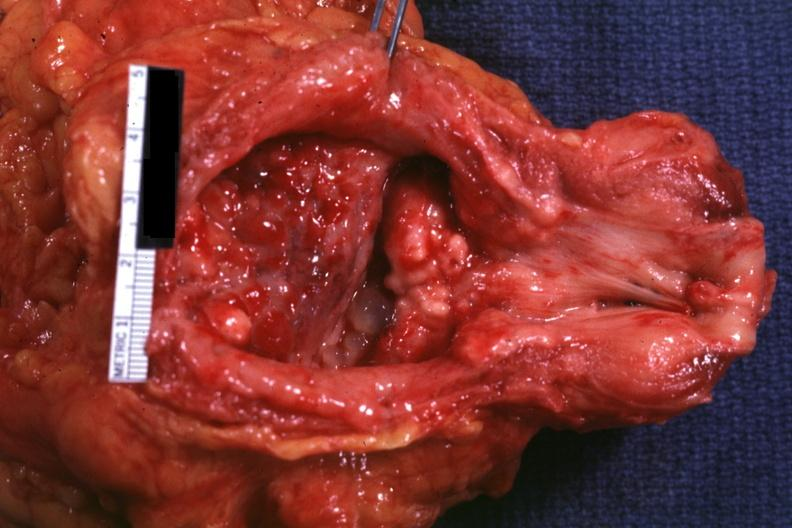what is present?
Answer the question using a single word or phrase. Prostate 